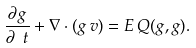<formula> <loc_0><loc_0><loc_500><loc_500>\frac { \partial g } { \partial \ t } + \nabla \cdot ( g \, v ) = E \, Q ( g , g ) .</formula> 